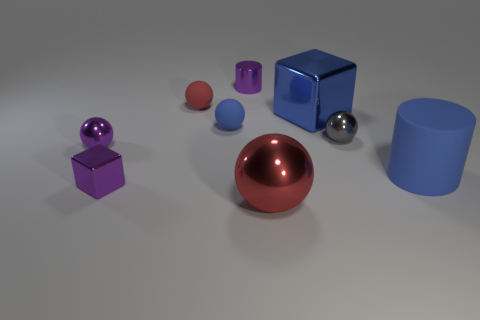Subtract 1 spheres. How many spheres are left? 4 Add 1 gray objects. How many objects exist? 10 Subtract all blocks. How many objects are left? 7 Add 4 tiny red objects. How many tiny red objects are left? 5 Add 5 tiny red rubber balls. How many tiny red rubber balls exist? 6 Subtract 0 gray cubes. How many objects are left? 9 Subtract all cyan rubber cylinders. Subtract all blue cylinders. How many objects are left? 8 